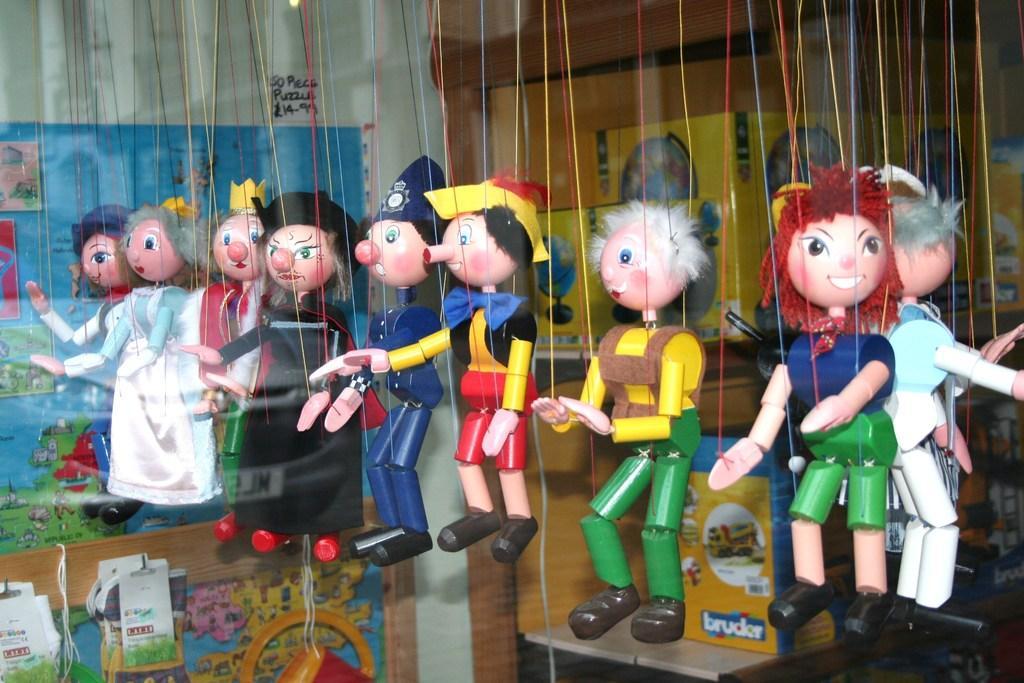Could you give a brief overview of what you see in this image? In this image there are toys, there is a table towards the bottom of the image, there are boxes on the table, there is a wall, there is text on the wall, there are objects towards the left of the image, there are objects towards the bottom of the image, there is a wooden object behind the boxes. 